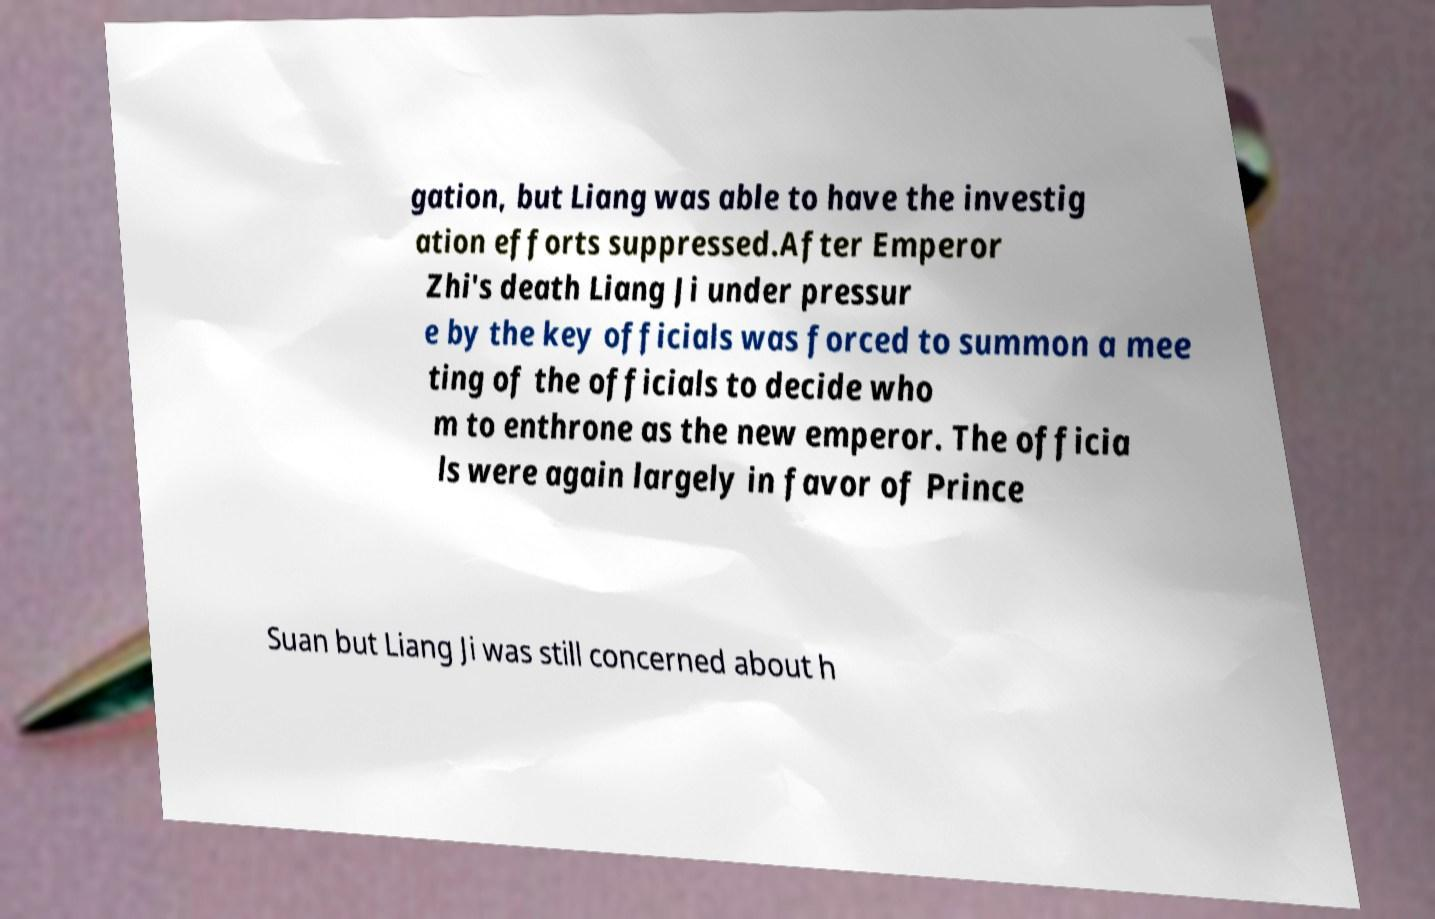Please read and relay the text visible in this image. What does it say? gation, but Liang was able to have the investig ation efforts suppressed.After Emperor Zhi's death Liang Ji under pressur e by the key officials was forced to summon a mee ting of the officials to decide who m to enthrone as the new emperor. The officia ls were again largely in favor of Prince Suan but Liang Ji was still concerned about h 